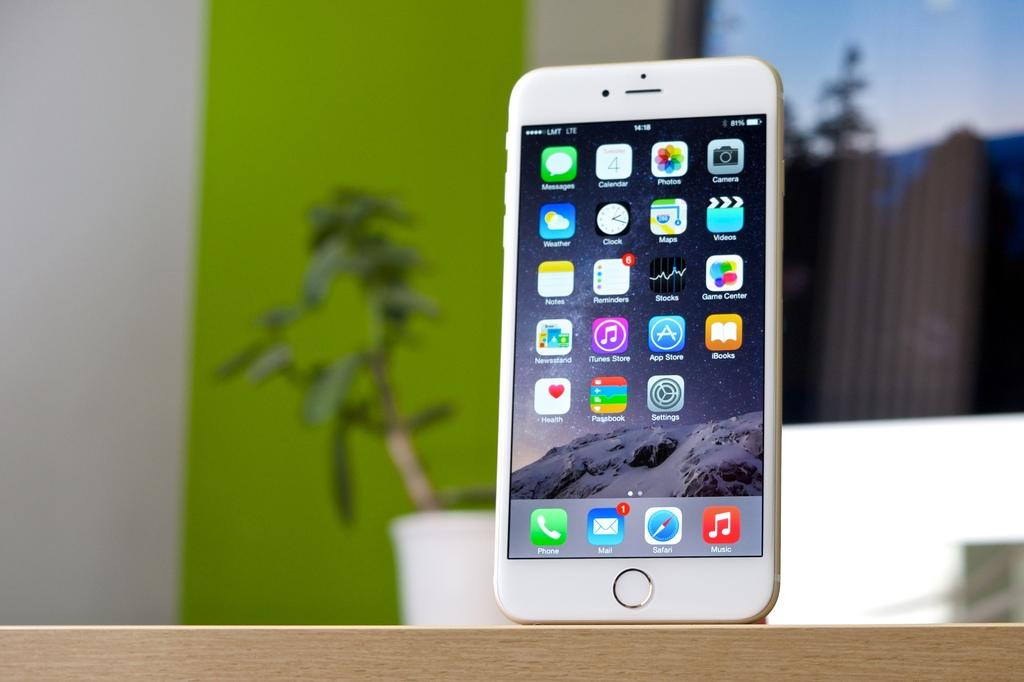<image>
Create a compact narrative representing the image presented. A cell phone shows that there is one unread email. 